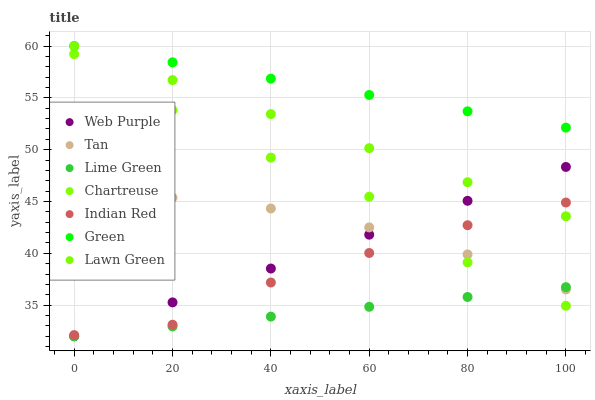Does Lime Green have the minimum area under the curve?
Answer yes or no. Yes. Does Green have the maximum area under the curve?
Answer yes or no. Yes. Does Chartreuse have the minimum area under the curve?
Answer yes or no. No. Does Chartreuse have the maximum area under the curve?
Answer yes or no. No. Is Green the smoothest?
Answer yes or no. Yes. Is Chartreuse the roughest?
Answer yes or no. Yes. Is Web Purple the smoothest?
Answer yes or no. No. Is Web Purple the roughest?
Answer yes or no. No. Does Web Purple have the lowest value?
Answer yes or no. Yes. Does Chartreuse have the lowest value?
Answer yes or no. No. Does Green have the highest value?
Answer yes or no. Yes. Does Chartreuse have the highest value?
Answer yes or no. No. Is Lime Green less than Indian Red?
Answer yes or no. Yes. Is Green greater than Web Purple?
Answer yes or no. Yes. Does Chartreuse intersect Tan?
Answer yes or no. Yes. Is Chartreuse less than Tan?
Answer yes or no. No. Is Chartreuse greater than Tan?
Answer yes or no. No. Does Lime Green intersect Indian Red?
Answer yes or no. No. 